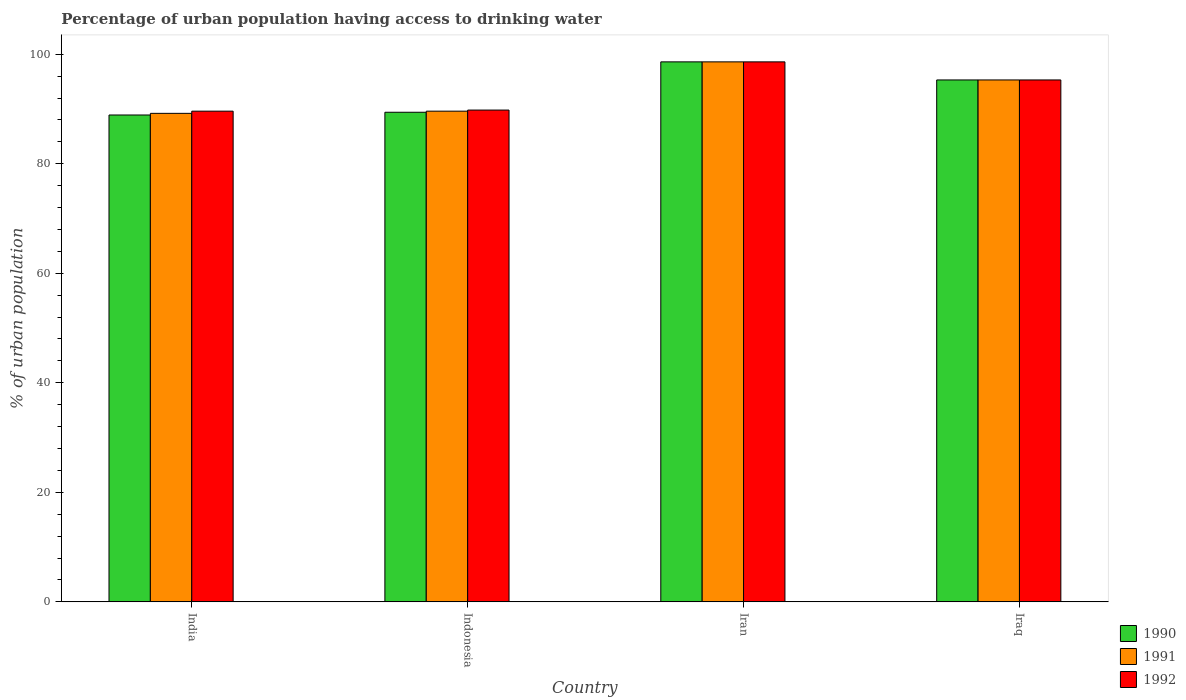How many groups of bars are there?
Make the answer very short. 4. How many bars are there on the 1st tick from the left?
Keep it short and to the point. 3. What is the label of the 4th group of bars from the left?
Provide a short and direct response. Iraq. In how many cases, is the number of bars for a given country not equal to the number of legend labels?
Your response must be concise. 0. What is the percentage of urban population having access to drinking water in 1990 in India?
Your response must be concise. 88.9. Across all countries, what is the maximum percentage of urban population having access to drinking water in 1990?
Offer a very short reply. 98.6. Across all countries, what is the minimum percentage of urban population having access to drinking water in 1992?
Your response must be concise. 89.6. In which country was the percentage of urban population having access to drinking water in 1992 maximum?
Ensure brevity in your answer.  Iran. In which country was the percentage of urban population having access to drinking water in 1990 minimum?
Provide a short and direct response. India. What is the total percentage of urban population having access to drinking water in 1991 in the graph?
Your response must be concise. 372.7. What is the difference between the percentage of urban population having access to drinking water in 1991 in Indonesia and that in Iraq?
Your answer should be very brief. -5.7. What is the difference between the percentage of urban population having access to drinking water in 1990 in India and the percentage of urban population having access to drinking water in 1992 in Iran?
Your response must be concise. -9.7. What is the average percentage of urban population having access to drinking water in 1990 per country?
Provide a short and direct response. 93.05. What is the difference between the percentage of urban population having access to drinking water of/in 1991 and percentage of urban population having access to drinking water of/in 1992 in Iran?
Ensure brevity in your answer.  0. What is the ratio of the percentage of urban population having access to drinking water in 1992 in India to that in Iraq?
Offer a terse response. 0.94. Is the percentage of urban population having access to drinking water in 1991 in India less than that in Indonesia?
Make the answer very short. Yes. What is the difference between the highest and the second highest percentage of urban population having access to drinking water in 1990?
Offer a very short reply. -9.2. What is the difference between the highest and the lowest percentage of urban population having access to drinking water in 1991?
Ensure brevity in your answer.  9.4. Is the sum of the percentage of urban population having access to drinking water in 1990 in Indonesia and Iraq greater than the maximum percentage of urban population having access to drinking water in 1992 across all countries?
Provide a short and direct response. Yes. What does the 3rd bar from the left in India represents?
Make the answer very short. 1992. What does the 2nd bar from the right in Indonesia represents?
Keep it short and to the point. 1991. Are all the bars in the graph horizontal?
Provide a short and direct response. No. How many countries are there in the graph?
Your answer should be very brief. 4. Are the values on the major ticks of Y-axis written in scientific E-notation?
Your answer should be compact. No. Does the graph contain any zero values?
Offer a terse response. No. Does the graph contain grids?
Your answer should be compact. No. Where does the legend appear in the graph?
Offer a very short reply. Bottom right. How many legend labels are there?
Provide a short and direct response. 3. What is the title of the graph?
Make the answer very short. Percentage of urban population having access to drinking water. What is the label or title of the Y-axis?
Provide a succinct answer. % of urban population. What is the % of urban population in 1990 in India?
Offer a very short reply. 88.9. What is the % of urban population of 1991 in India?
Your response must be concise. 89.2. What is the % of urban population of 1992 in India?
Ensure brevity in your answer.  89.6. What is the % of urban population of 1990 in Indonesia?
Your answer should be very brief. 89.4. What is the % of urban population of 1991 in Indonesia?
Provide a succinct answer. 89.6. What is the % of urban population of 1992 in Indonesia?
Offer a very short reply. 89.8. What is the % of urban population in 1990 in Iran?
Give a very brief answer. 98.6. What is the % of urban population of 1991 in Iran?
Make the answer very short. 98.6. What is the % of urban population in 1992 in Iran?
Provide a succinct answer. 98.6. What is the % of urban population in 1990 in Iraq?
Keep it short and to the point. 95.3. What is the % of urban population of 1991 in Iraq?
Offer a terse response. 95.3. What is the % of urban population in 1992 in Iraq?
Give a very brief answer. 95.3. Across all countries, what is the maximum % of urban population of 1990?
Keep it short and to the point. 98.6. Across all countries, what is the maximum % of urban population in 1991?
Keep it short and to the point. 98.6. Across all countries, what is the maximum % of urban population of 1992?
Ensure brevity in your answer.  98.6. Across all countries, what is the minimum % of urban population in 1990?
Your answer should be compact. 88.9. Across all countries, what is the minimum % of urban population in 1991?
Keep it short and to the point. 89.2. Across all countries, what is the minimum % of urban population in 1992?
Provide a short and direct response. 89.6. What is the total % of urban population in 1990 in the graph?
Offer a terse response. 372.2. What is the total % of urban population of 1991 in the graph?
Your response must be concise. 372.7. What is the total % of urban population in 1992 in the graph?
Offer a very short reply. 373.3. What is the difference between the % of urban population of 1991 in India and that in Iran?
Your response must be concise. -9.4. What is the difference between the % of urban population of 1991 in India and that in Iraq?
Make the answer very short. -6.1. What is the difference between the % of urban population of 1992 in India and that in Iraq?
Make the answer very short. -5.7. What is the difference between the % of urban population in 1990 in Indonesia and that in Iran?
Your answer should be compact. -9.2. What is the difference between the % of urban population in 1991 in Indonesia and that in Iran?
Keep it short and to the point. -9. What is the difference between the % of urban population of 1991 in Indonesia and that in Iraq?
Give a very brief answer. -5.7. What is the difference between the % of urban population of 1992 in Indonesia and that in Iraq?
Ensure brevity in your answer.  -5.5. What is the difference between the % of urban population in 1990 in Iran and that in Iraq?
Make the answer very short. 3.3. What is the difference between the % of urban population in 1991 in Iran and that in Iraq?
Give a very brief answer. 3.3. What is the difference between the % of urban population in 1992 in Iran and that in Iraq?
Make the answer very short. 3.3. What is the difference between the % of urban population in 1990 in India and the % of urban population in 1991 in Indonesia?
Offer a terse response. -0.7. What is the difference between the % of urban population of 1990 in India and the % of urban population of 1991 in Iran?
Provide a succinct answer. -9.7. What is the difference between the % of urban population of 1990 in India and the % of urban population of 1992 in Iran?
Give a very brief answer. -9.7. What is the difference between the % of urban population of 1991 in India and the % of urban population of 1992 in Iraq?
Provide a succinct answer. -6.1. What is the difference between the % of urban population in 1990 in Indonesia and the % of urban population in 1991 in Iran?
Ensure brevity in your answer.  -9.2. What is the difference between the % of urban population in 1990 in Indonesia and the % of urban population in 1992 in Iran?
Provide a short and direct response. -9.2. What is the difference between the % of urban population of 1991 in Indonesia and the % of urban population of 1992 in Iran?
Give a very brief answer. -9. What is the difference between the % of urban population of 1990 in Iran and the % of urban population of 1991 in Iraq?
Ensure brevity in your answer.  3.3. What is the difference between the % of urban population of 1990 in Iran and the % of urban population of 1992 in Iraq?
Give a very brief answer. 3.3. What is the difference between the % of urban population in 1991 in Iran and the % of urban population in 1992 in Iraq?
Provide a short and direct response. 3.3. What is the average % of urban population in 1990 per country?
Offer a very short reply. 93.05. What is the average % of urban population of 1991 per country?
Your answer should be compact. 93.17. What is the average % of urban population in 1992 per country?
Give a very brief answer. 93.33. What is the difference between the % of urban population of 1990 and % of urban population of 1991 in Indonesia?
Ensure brevity in your answer.  -0.2. What is the difference between the % of urban population in 1990 and % of urban population in 1992 in Indonesia?
Provide a short and direct response. -0.4. What is the difference between the % of urban population in 1990 and % of urban population in 1991 in Iran?
Provide a succinct answer. 0. What is the difference between the % of urban population in 1991 and % of urban population in 1992 in Iran?
Your answer should be very brief. 0. What is the difference between the % of urban population in 1990 and % of urban population in 1991 in Iraq?
Offer a very short reply. 0. What is the difference between the % of urban population in 1990 and % of urban population in 1992 in Iraq?
Your answer should be very brief. 0. What is the difference between the % of urban population of 1991 and % of urban population of 1992 in Iraq?
Give a very brief answer. 0. What is the ratio of the % of urban population of 1990 in India to that in Indonesia?
Ensure brevity in your answer.  0.99. What is the ratio of the % of urban population of 1991 in India to that in Indonesia?
Make the answer very short. 1. What is the ratio of the % of urban population of 1992 in India to that in Indonesia?
Keep it short and to the point. 1. What is the ratio of the % of urban population in 1990 in India to that in Iran?
Offer a terse response. 0.9. What is the ratio of the % of urban population of 1991 in India to that in Iran?
Your response must be concise. 0.9. What is the ratio of the % of urban population of 1992 in India to that in Iran?
Provide a short and direct response. 0.91. What is the ratio of the % of urban population in 1990 in India to that in Iraq?
Provide a succinct answer. 0.93. What is the ratio of the % of urban population of 1991 in India to that in Iraq?
Your response must be concise. 0.94. What is the ratio of the % of urban population in 1992 in India to that in Iraq?
Provide a short and direct response. 0.94. What is the ratio of the % of urban population in 1990 in Indonesia to that in Iran?
Provide a succinct answer. 0.91. What is the ratio of the % of urban population in 1991 in Indonesia to that in Iran?
Give a very brief answer. 0.91. What is the ratio of the % of urban population of 1992 in Indonesia to that in Iran?
Provide a short and direct response. 0.91. What is the ratio of the % of urban population of 1990 in Indonesia to that in Iraq?
Make the answer very short. 0.94. What is the ratio of the % of urban population of 1991 in Indonesia to that in Iraq?
Ensure brevity in your answer.  0.94. What is the ratio of the % of urban population in 1992 in Indonesia to that in Iraq?
Your response must be concise. 0.94. What is the ratio of the % of urban population in 1990 in Iran to that in Iraq?
Provide a succinct answer. 1.03. What is the ratio of the % of urban population of 1991 in Iran to that in Iraq?
Keep it short and to the point. 1.03. What is the ratio of the % of urban population of 1992 in Iran to that in Iraq?
Your answer should be very brief. 1.03. What is the difference between the highest and the second highest % of urban population of 1990?
Your answer should be very brief. 3.3. What is the difference between the highest and the second highest % of urban population in 1991?
Ensure brevity in your answer.  3.3. 